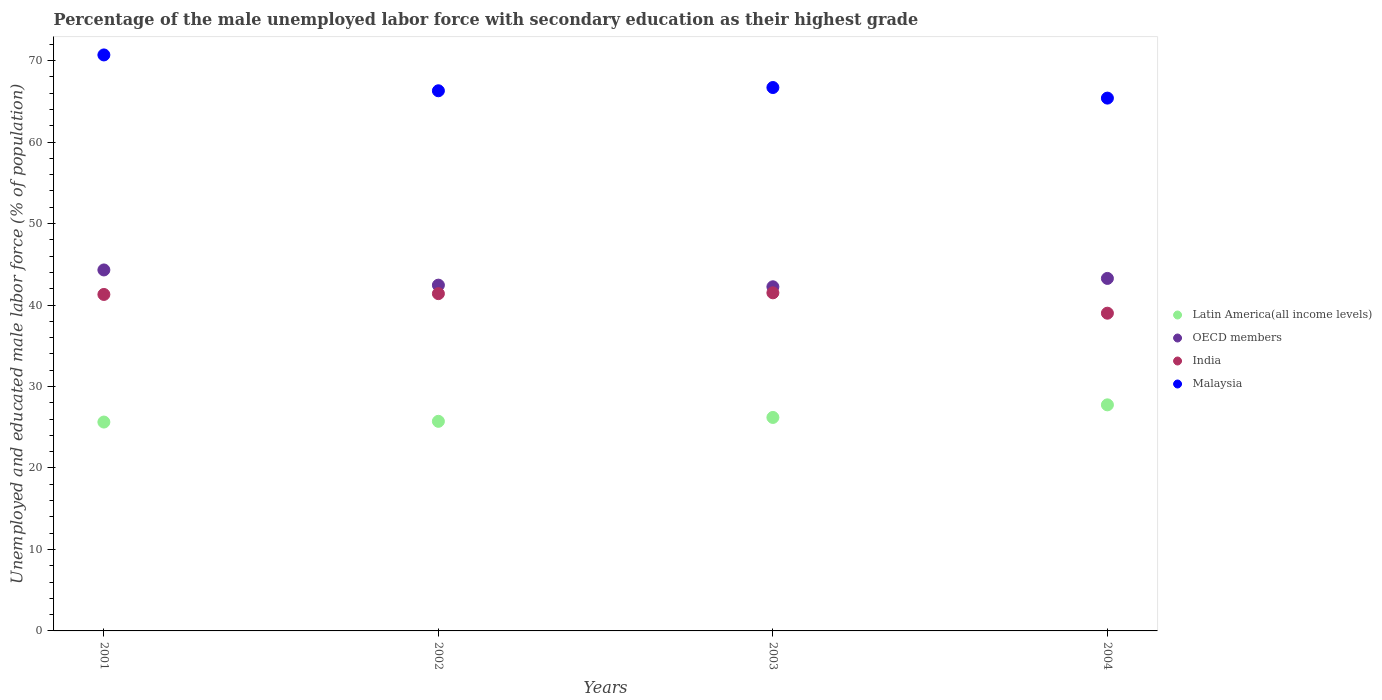How many different coloured dotlines are there?
Your answer should be very brief. 4. What is the percentage of the unemployed male labor force with secondary education in OECD members in 2004?
Offer a very short reply. 43.27. Across all years, what is the maximum percentage of the unemployed male labor force with secondary education in OECD members?
Offer a very short reply. 44.31. Across all years, what is the minimum percentage of the unemployed male labor force with secondary education in Latin America(all income levels)?
Keep it short and to the point. 25.64. In which year was the percentage of the unemployed male labor force with secondary education in India maximum?
Provide a short and direct response. 2003. What is the total percentage of the unemployed male labor force with secondary education in India in the graph?
Offer a very short reply. 163.2. What is the difference between the percentage of the unemployed male labor force with secondary education in Latin America(all income levels) in 2001 and that in 2002?
Offer a very short reply. -0.09. What is the difference between the percentage of the unemployed male labor force with secondary education in India in 2003 and the percentage of the unemployed male labor force with secondary education in Malaysia in 2001?
Provide a short and direct response. -29.2. What is the average percentage of the unemployed male labor force with secondary education in India per year?
Make the answer very short. 40.8. In the year 2002, what is the difference between the percentage of the unemployed male labor force with secondary education in Latin America(all income levels) and percentage of the unemployed male labor force with secondary education in OECD members?
Your response must be concise. -16.71. What is the ratio of the percentage of the unemployed male labor force with secondary education in Malaysia in 2002 to that in 2004?
Give a very brief answer. 1.01. Is the percentage of the unemployed male labor force with secondary education in India in 2003 less than that in 2004?
Provide a succinct answer. No. What is the difference between the highest and the second highest percentage of the unemployed male labor force with secondary education in Latin America(all income levels)?
Make the answer very short. 1.55. Is the sum of the percentage of the unemployed male labor force with secondary education in Malaysia in 2002 and 2004 greater than the maximum percentage of the unemployed male labor force with secondary education in OECD members across all years?
Make the answer very short. Yes. Is it the case that in every year, the sum of the percentage of the unemployed male labor force with secondary education in Latin America(all income levels) and percentage of the unemployed male labor force with secondary education in OECD members  is greater than the sum of percentage of the unemployed male labor force with secondary education in Malaysia and percentage of the unemployed male labor force with secondary education in India?
Provide a succinct answer. No. Does the percentage of the unemployed male labor force with secondary education in Latin America(all income levels) monotonically increase over the years?
Offer a terse response. Yes. Is the percentage of the unemployed male labor force with secondary education in Malaysia strictly less than the percentage of the unemployed male labor force with secondary education in Latin America(all income levels) over the years?
Your answer should be very brief. No. What is the difference between two consecutive major ticks on the Y-axis?
Offer a terse response. 10. Does the graph contain any zero values?
Provide a succinct answer. No. Does the graph contain grids?
Offer a terse response. No. What is the title of the graph?
Ensure brevity in your answer.  Percentage of the male unemployed labor force with secondary education as their highest grade. What is the label or title of the X-axis?
Your answer should be very brief. Years. What is the label or title of the Y-axis?
Your answer should be very brief. Unemployed and educated male labor force (% of population). What is the Unemployed and educated male labor force (% of population) in Latin America(all income levels) in 2001?
Your answer should be compact. 25.64. What is the Unemployed and educated male labor force (% of population) of OECD members in 2001?
Provide a succinct answer. 44.31. What is the Unemployed and educated male labor force (% of population) in India in 2001?
Give a very brief answer. 41.3. What is the Unemployed and educated male labor force (% of population) of Malaysia in 2001?
Provide a succinct answer. 70.7. What is the Unemployed and educated male labor force (% of population) of Latin America(all income levels) in 2002?
Offer a terse response. 25.73. What is the Unemployed and educated male labor force (% of population) in OECD members in 2002?
Ensure brevity in your answer.  42.44. What is the Unemployed and educated male labor force (% of population) of India in 2002?
Give a very brief answer. 41.4. What is the Unemployed and educated male labor force (% of population) in Malaysia in 2002?
Keep it short and to the point. 66.3. What is the Unemployed and educated male labor force (% of population) of Latin America(all income levels) in 2003?
Your answer should be very brief. 26.2. What is the Unemployed and educated male labor force (% of population) in OECD members in 2003?
Your response must be concise. 42.24. What is the Unemployed and educated male labor force (% of population) of India in 2003?
Provide a succinct answer. 41.5. What is the Unemployed and educated male labor force (% of population) of Malaysia in 2003?
Make the answer very short. 66.7. What is the Unemployed and educated male labor force (% of population) in Latin America(all income levels) in 2004?
Your response must be concise. 27.75. What is the Unemployed and educated male labor force (% of population) in OECD members in 2004?
Offer a very short reply. 43.27. What is the Unemployed and educated male labor force (% of population) in India in 2004?
Offer a terse response. 39. What is the Unemployed and educated male labor force (% of population) of Malaysia in 2004?
Offer a terse response. 65.4. Across all years, what is the maximum Unemployed and educated male labor force (% of population) of Latin America(all income levels)?
Give a very brief answer. 27.75. Across all years, what is the maximum Unemployed and educated male labor force (% of population) in OECD members?
Ensure brevity in your answer.  44.31. Across all years, what is the maximum Unemployed and educated male labor force (% of population) in India?
Your answer should be very brief. 41.5. Across all years, what is the maximum Unemployed and educated male labor force (% of population) of Malaysia?
Make the answer very short. 70.7. Across all years, what is the minimum Unemployed and educated male labor force (% of population) of Latin America(all income levels)?
Offer a terse response. 25.64. Across all years, what is the minimum Unemployed and educated male labor force (% of population) in OECD members?
Offer a very short reply. 42.24. Across all years, what is the minimum Unemployed and educated male labor force (% of population) of India?
Your answer should be very brief. 39. Across all years, what is the minimum Unemployed and educated male labor force (% of population) in Malaysia?
Ensure brevity in your answer.  65.4. What is the total Unemployed and educated male labor force (% of population) of Latin America(all income levels) in the graph?
Give a very brief answer. 105.32. What is the total Unemployed and educated male labor force (% of population) of OECD members in the graph?
Ensure brevity in your answer.  172.26. What is the total Unemployed and educated male labor force (% of population) of India in the graph?
Provide a short and direct response. 163.2. What is the total Unemployed and educated male labor force (% of population) in Malaysia in the graph?
Your response must be concise. 269.1. What is the difference between the Unemployed and educated male labor force (% of population) in Latin America(all income levels) in 2001 and that in 2002?
Ensure brevity in your answer.  -0.09. What is the difference between the Unemployed and educated male labor force (% of population) in OECD members in 2001 and that in 2002?
Your answer should be very brief. 1.87. What is the difference between the Unemployed and educated male labor force (% of population) in India in 2001 and that in 2002?
Your answer should be compact. -0.1. What is the difference between the Unemployed and educated male labor force (% of population) of Latin America(all income levels) in 2001 and that in 2003?
Your response must be concise. -0.57. What is the difference between the Unemployed and educated male labor force (% of population) in OECD members in 2001 and that in 2003?
Ensure brevity in your answer.  2.07. What is the difference between the Unemployed and educated male labor force (% of population) in India in 2001 and that in 2003?
Offer a very short reply. -0.2. What is the difference between the Unemployed and educated male labor force (% of population) of Latin America(all income levels) in 2001 and that in 2004?
Provide a short and direct response. -2.11. What is the difference between the Unemployed and educated male labor force (% of population) of OECD members in 2001 and that in 2004?
Your response must be concise. 1.04. What is the difference between the Unemployed and educated male labor force (% of population) in Malaysia in 2001 and that in 2004?
Give a very brief answer. 5.3. What is the difference between the Unemployed and educated male labor force (% of population) of Latin America(all income levels) in 2002 and that in 2003?
Your response must be concise. -0.48. What is the difference between the Unemployed and educated male labor force (% of population) of OECD members in 2002 and that in 2003?
Keep it short and to the point. 0.2. What is the difference between the Unemployed and educated male labor force (% of population) of India in 2002 and that in 2003?
Provide a succinct answer. -0.1. What is the difference between the Unemployed and educated male labor force (% of population) in Latin America(all income levels) in 2002 and that in 2004?
Offer a very short reply. -2.02. What is the difference between the Unemployed and educated male labor force (% of population) of OECD members in 2002 and that in 2004?
Your answer should be compact. -0.83. What is the difference between the Unemployed and educated male labor force (% of population) of India in 2002 and that in 2004?
Make the answer very short. 2.4. What is the difference between the Unemployed and educated male labor force (% of population) in Malaysia in 2002 and that in 2004?
Your answer should be compact. 0.9. What is the difference between the Unemployed and educated male labor force (% of population) of Latin America(all income levels) in 2003 and that in 2004?
Give a very brief answer. -1.55. What is the difference between the Unemployed and educated male labor force (% of population) of OECD members in 2003 and that in 2004?
Keep it short and to the point. -1.03. What is the difference between the Unemployed and educated male labor force (% of population) in India in 2003 and that in 2004?
Give a very brief answer. 2.5. What is the difference between the Unemployed and educated male labor force (% of population) of Latin America(all income levels) in 2001 and the Unemployed and educated male labor force (% of population) of OECD members in 2002?
Your response must be concise. -16.81. What is the difference between the Unemployed and educated male labor force (% of population) in Latin America(all income levels) in 2001 and the Unemployed and educated male labor force (% of population) in India in 2002?
Offer a terse response. -15.76. What is the difference between the Unemployed and educated male labor force (% of population) in Latin America(all income levels) in 2001 and the Unemployed and educated male labor force (% of population) in Malaysia in 2002?
Your response must be concise. -40.66. What is the difference between the Unemployed and educated male labor force (% of population) of OECD members in 2001 and the Unemployed and educated male labor force (% of population) of India in 2002?
Your answer should be very brief. 2.91. What is the difference between the Unemployed and educated male labor force (% of population) of OECD members in 2001 and the Unemployed and educated male labor force (% of population) of Malaysia in 2002?
Your response must be concise. -21.99. What is the difference between the Unemployed and educated male labor force (% of population) in India in 2001 and the Unemployed and educated male labor force (% of population) in Malaysia in 2002?
Make the answer very short. -25. What is the difference between the Unemployed and educated male labor force (% of population) of Latin America(all income levels) in 2001 and the Unemployed and educated male labor force (% of population) of OECD members in 2003?
Give a very brief answer. -16.6. What is the difference between the Unemployed and educated male labor force (% of population) in Latin America(all income levels) in 2001 and the Unemployed and educated male labor force (% of population) in India in 2003?
Provide a short and direct response. -15.86. What is the difference between the Unemployed and educated male labor force (% of population) in Latin America(all income levels) in 2001 and the Unemployed and educated male labor force (% of population) in Malaysia in 2003?
Provide a short and direct response. -41.06. What is the difference between the Unemployed and educated male labor force (% of population) in OECD members in 2001 and the Unemployed and educated male labor force (% of population) in India in 2003?
Offer a very short reply. 2.81. What is the difference between the Unemployed and educated male labor force (% of population) in OECD members in 2001 and the Unemployed and educated male labor force (% of population) in Malaysia in 2003?
Offer a terse response. -22.39. What is the difference between the Unemployed and educated male labor force (% of population) of India in 2001 and the Unemployed and educated male labor force (% of population) of Malaysia in 2003?
Provide a short and direct response. -25.4. What is the difference between the Unemployed and educated male labor force (% of population) of Latin America(all income levels) in 2001 and the Unemployed and educated male labor force (% of population) of OECD members in 2004?
Provide a short and direct response. -17.63. What is the difference between the Unemployed and educated male labor force (% of population) in Latin America(all income levels) in 2001 and the Unemployed and educated male labor force (% of population) in India in 2004?
Your answer should be very brief. -13.36. What is the difference between the Unemployed and educated male labor force (% of population) in Latin America(all income levels) in 2001 and the Unemployed and educated male labor force (% of population) in Malaysia in 2004?
Give a very brief answer. -39.76. What is the difference between the Unemployed and educated male labor force (% of population) in OECD members in 2001 and the Unemployed and educated male labor force (% of population) in India in 2004?
Make the answer very short. 5.31. What is the difference between the Unemployed and educated male labor force (% of population) of OECD members in 2001 and the Unemployed and educated male labor force (% of population) of Malaysia in 2004?
Keep it short and to the point. -21.09. What is the difference between the Unemployed and educated male labor force (% of population) in India in 2001 and the Unemployed and educated male labor force (% of population) in Malaysia in 2004?
Your response must be concise. -24.1. What is the difference between the Unemployed and educated male labor force (% of population) in Latin America(all income levels) in 2002 and the Unemployed and educated male labor force (% of population) in OECD members in 2003?
Provide a short and direct response. -16.51. What is the difference between the Unemployed and educated male labor force (% of population) in Latin America(all income levels) in 2002 and the Unemployed and educated male labor force (% of population) in India in 2003?
Provide a short and direct response. -15.77. What is the difference between the Unemployed and educated male labor force (% of population) in Latin America(all income levels) in 2002 and the Unemployed and educated male labor force (% of population) in Malaysia in 2003?
Offer a terse response. -40.97. What is the difference between the Unemployed and educated male labor force (% of population) of OECD members in 2002 and the Unemployed and educated male labor force (% of population) of India in 2003?
Your answer should be very brief. 0.94. What is the difference between the Unemployed and educated male labor force (% of population) in OECD members in 2002 and the Unemployed and educated male labor force (% of population) in Malaysia in 2003?
Your answer should be compact. -24.26. What is the difference between the Unemployed and educated male labor force (% of population) in India in 2002 and the Unemployed and educated male labor force (% of population) in Malaysia in 2003?
Offer a terse response. -25.3. What is the difference between the Unemployed and educated male labor force (% of population) of Latin America(all income levels) in 2002 and the Unemployed and educated male labor force (% of population) of OECD members in 2004?
Give a very brief answer. -17.54. What is the difference between the Unemployed and educated male labor force (% of population) in Latin America(all income levels) in 2002 and the Unemployed and educated male labor force (% of population) in India in 2004?
Your answer should be very brief. -13.27. What is the difference between the Unemployed and educated male labor force (% of population) of Latin America(all income levels) in 2002 and the Unemployed and educated male labor force (% of population) of Malaysia in 2004?
Your answer should be very brief. -39.67. What is the difference between the Unemployed and educated male labor force (% of population) of OECD members in 2002 and the Unemployed and educated male labor force (% of population) of India in 2004?
Give a very brief answer. 3.44. What is the difference between the Unemployed and educated male labor force (% of population) of OECD members in 2002 and the Unemployed and educated male labor force (% of population) of Malaysia in 2004?
Keep it short and to the point. -22.96. What is the difference between the Unemployed and educated male labor force (% of population) in India in 2002 and the Unemployed and educated male labor force (% of population) in Malaysia in 2004?
Offer a terse response. -24. What is the difference between the Unemployed and educated male labor force (% of population) of Latin America(all income levels) in 2003 and the Unemployed and educated male labor force (% of population) of OECD members in 2004?
Ensure brevity in your answer.  -17.07. What is the difference between the Unemployed and educated male labor force (% of population) of Latin America(all income levels) in 2003 and the Unemployed and educated male labor force (% of population) of India in 2004?
Give a very brief answer. -12.8. What is the difference between the Unemployed and educated male labor force (% of population) in Latin America(all income levels) in 2003 and the Unemployed and educated male labor force (% of population) in Malaysia in 2004?
Make the answer very short. -39.2. What is the difference between the Unemployed and educated male labor force (% of population) of OECD members in 2003 and the Unemployed and educated male labor force (% of population) of India in 2004?
Ensure brevity in your answer.  3.24. What is the difference between the Unemployed and educated male labor force (% of population) of OECD members in 2003 and the Unemployed and educated male labor force (% of population) of Malaysia in 2004?
Make the answer very short. -23.16. What is the difference between the Unemployed and educated male labor force (% of population) of India in 2003 and the Unemployed and educated male labor force (% of population) of Malaysia in 2004?
Give a very brief answer. -23.9. What is the average Unemployed and educated male labor force (% of population) in Latin America(all income levels) per year?
Your answer should be very brief. 26.33. What is the average Unemployed and educated male labor force (% of population) in OECD members per year?
Provide a short and direct response. 43.06. What is the average Unemployed and educated male labor force (% of population) in India per year?
Provide a succinct answer. 40.8. What is the average Unemployed and educated male labor force (% of population) of Malaysia per year?
Your answer should be very brief. 67.28. In the year 2001, what is the difference between the Unemployed and educated male labor force (% of population) in Latin America(all income levels) and Unemployed and educated male labor force (% of population) in OECD members?
Make the answer very short. -18.67. In the year 2001, what is the difference between the Unemployed and educated male labor force (% of population) in Latin America(all income levels) and Unemployed and educated male labor force (% of population) in India?
Your response must be concise. -15.66. In the year 2001, what is the difference between the Unemployed and educated male labor force (% of population) in Latin America(all income levels) and Unemployed and educated male labor force (% of population) in Malaysia?
Keep it short and to the point. -45.06. In the year 2001, what is the difference between the Unemployed and educated male labor force (% of population) of OECD members and Unemployed and educated male labor force (% of population) of India?
Your response must be concise. 3.01. In the year 2001, what is the difference between the Unemployed and educated male labor force (% of population) of OECD members and Unemployed and educated male labor force (% of population) of Malaysia?
Give a very brief answer. -26.39. In the year 2001, what is the difference between the Unemployed and educated male labor force (% of population) of India and Unemployed and educated male labor force (% of population) of Malaysia?
Provide a succinct answer. -29.4. In the year 2002, what is the difference between the Unemployed and educated male labor force (% of population) in Latin America(all income levels) and Unemployed and educated male labor force (% of population) in OECD members?
Provide a succinct answer. -16.71. In the year 2002, what is the difference between the Unemployed and educated male labor force (% of population) of Latin America(all income levels) and Unemployed and educated male labor force (% of population) of India?
Provide a succinct answer. -15.67. In the year 2002, what is the difference between the Unemployed and educated male labor force (% of population) in Latin America(all income levels) and Unemployed and educated male labor force (% of population) in Malaysia?
Your response must be concise. -40.57. In the year 2002, what is the difference between the Unemployed and educated male labor force (% of population) in OECD members and Unemployed and educated male labor force (% of population) in India?
Keep it short and to the point. 1.04. In the year 2002, what is the difference between the Unemployed and educated male labor force (% of population) of OECD members and Unemployed and educated male labor force (% of population) of Malaysia?
Give a very brief answer. -23.86. In the year 2002, what is the difference between the Unemployed and educated male labor force (% of population) in India and Unemployed and educated male labor force (% of population) in Malaysia?
Ensure brevity in your answer.  -24.9. In the year 2003, what is the difference between the Unemployed and educated male labor force (% of population) of Latin America(all income levels) and Unemployed and educated male labor force (% of population) of OECD members?
Give a very brief answer. -16.04. In the year 2003, what is the difference between the Unemployed and educated male labor force (% of population) in Latin America(all income levels) and Unemployed and educated male labor force (% of population) in India?
Ensure brevity in your answer.  -15.3. In the year 2003, what is the difference between the Unemployed and educated male labor force (% of population) in Latin America(all income levels) and Unemployed and educated male labor force (% of population) in Malaysia?
Keep it short and to the point. -40.5. In the year 2003, what is the difference between the Unemployed and educated male labor force (% of population) of OECD members and Unemployed and educated male labor force (% of population) of India?
Ensure brevity in your answer.  0.74. In the year 2003, what is the difference between the Unemployed and educated male labor force (% of population) of OECD members and Unemployed and educated male labor force (% of population) of Malaysia?
Keep it short and to the point. -24.46. In the year 2003, what is the difference between the Unemployed and educated male labor force (% of population) of India and Unemployed and educated male labor force (% of population) of Malaysia?
Your response must be concise. -25.2. In the year 2004, what is the difference between the Unemployed and educated male labor force (% of population) in Latin America(all income levels) and Unemployed and educated male labor force (% of population) in OECD members?
Provide a short and direct response. -15.52. In the year 2004, what is the difference between the Unemployed and educated male labor force (% of population) in Latin America(all income levels) and Unemployed and educated male labor force (% of population) in India?
Ensure brevity in your answer.  -11.25. In the year 2004, what is the difference between the Unemployed and educated male labor force (% of population) of Latin America(all income levels) and Unemployed and educated male labor force (% of population) of Malaysia?
Your answer should be compact. -37.65. In the year 2004, what is the difference between the Unemployed and educated male labor force (% of population) of OECD members and Unemployed and educated male labor force (% of population) of India?
Provide a succinct answer. 4.27. In the year 2004, what is the difference between the Unemployed and educated male labor force (% of population) of OECD members and Unemployed and educated male labor force (% of population) of Malaysia?
Make the answer very short. -22.13. In the year 2004, what is the difference between the Unemployed and educated male labor force (% of population) of India and Unemployed and educated male labor force (% of population) of Malaysia?
Provide a short and direct response. -26.4. What is the ratio of the Unemployed and educated male labor force (% of population) in OECD members in 2001 to that in 2002?
Your answer should be compact. 1.04. What is the ratio of the Unemployed and educated male labor force (% of population) of India in 2001 to that in 2002?
Your answer should be compact. 1. What is the ratio of the Unemployed and educated male labor force (% of population) in Malaysia in 2001 to that in 2002?
Make the answer very short. 1.07. What is the ratio of the Unemployed and educated male labor force (% of population) in Latin America(all income levels) in 2001 to that in 2003?
Your response must be concise. 0.98. What is the ratio of the Unemployed and educated male labor force (% of population) of OECD members in 2001 to that in 2003?
Offer a very short reply. 1.05. What is the ratio of the Unemployed and educated male labor force (% of population) of India in 2001 to that in 2003?
Your answer should be very brief. 1. What is the ratio of the Unemployed and educated male labor force (% of population) in Malaysia in 2001 to that in 2003?
Provide a succinct answer. 1.06. What is the ratio of the Unemployed and educated male labor force (% of population) in Latin America(all income levels) in 2001 to that in 2004?
Your answer should be very brief. 0.92. What is the ratio of the Unemployed and educated male labor force (% of population) of India in 2001 to that in 2004?
Your answer should be very brief. 1.06. What is the ratio of the Unemployed and educated male labor force (% of population) of Malaysia in 2001 to that in 2004?
Provide a short and direct response. 1.08. What is the ratio of the Unemployed and educated male labor force (% of population) of Latin America(all income levels) in 2002 to that in 2003?
Keep it short and to the point. 0.98. What is the ratio of the Unemployed and educated male labor force (% of population) of OECD members in 2002 to that in 2003?
Offer a very short reply. 1. What is the ratio of the Unemployed and educated male labor force (% of population) in India in 2002 to that in 2003?
Keep it short and to the point. 1. What is the ratio of the Unemployed and educated male labor force (% of population) of Malaysia in 2002 to that in 2003?
Give a very brief answer. 0.99. What is the ratio of the Unemployed and educated male labor force (% of population) in Latin America(all income levels) in 2002 to that in 2004?
Give a very brief answer. 0.93. What is the ratio of the Unemployed and educated male labor force (% of population) of OECD members in 2002 to that in 2004?
Your answer should be compact. 0.98. What is the ratio of the Unemployed and educated male labor force (% of population) of India in 2002 to that in 2004?
Your response must be concise. 1.06. What is the ratio of the Unemployed and educated male labor force (% of population) of Malaysia in 2002 to that in 2004?
Offer a terse response. 1.01. What is the ratio of the Unemployed and educated male labor force (% of population) of Latin America(all income levels) in 2003 to that in 2004?
Offer a very short reply. 0.94. What is the ratio of the Unemployed and educated male labor force (% of population) in OECD members in 2003 to that in 2004?
Keep it short and to the point. 0.98. What is the ratio of the Unemployed and educated male labor force (% of population) of India in 2003 to that in 2004?
Provide a succinct answer. 1.06. What is the ratio of the Unemployed and educated male labor force (% of population) in Malaysia in 2003 to that in 2004?
Keep it short and to the point. 1.02. What is the difference between the highest and the second highest Unemployed and educated male labor force (% of population) of Latin America(all income levels)?
Your answer should be very brief. 1.55. What is the difference between the highest and the second highest Unemployed and educated male labor force (% of population) of OECD members?
Give a very brief answer. 1.04. What is the difference between the highest and the second highest Unemployed and educated male labor force (% of population) in India?
Your response must be concise. 0.1. What is the difference between the highest and the second highest Unemployed and educated male labor force (% of population) of Malaysia?
Your answer should be compact. 4. What is the difference between the highest and the lowest Unemployed and educated male labor force (% of population) in Latin America(all income levels)?
Keep it short and to the point. 2.11. What is the difference between the highest and the lowest Unemployed and educated male labor force (% of population) of OECD members?
Provide a short and direct response. 2.07. What is the difference between the highest and the lowest Unemployed and educated male labor force (% of population) in Malaysia?
Your response must be concise. 5.3. 